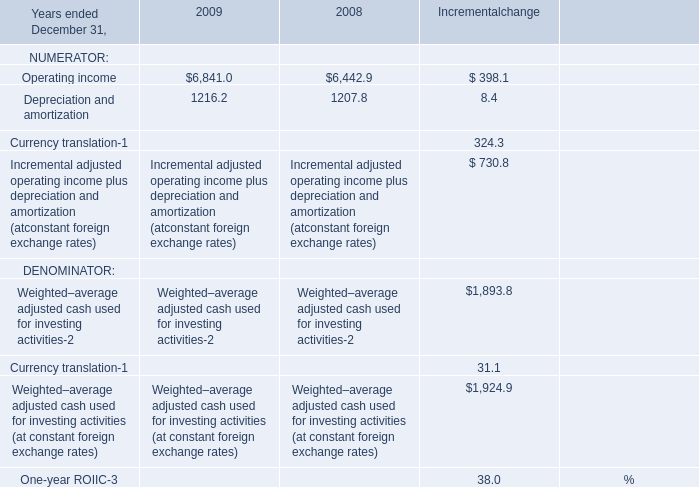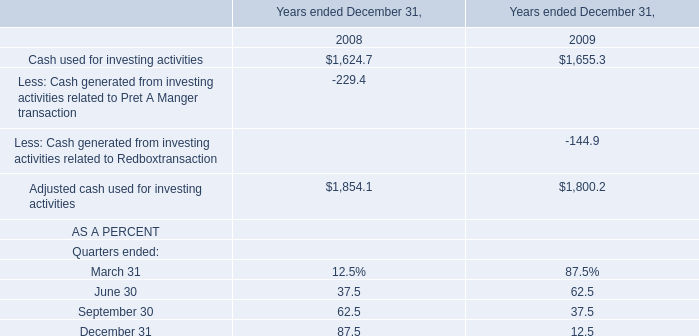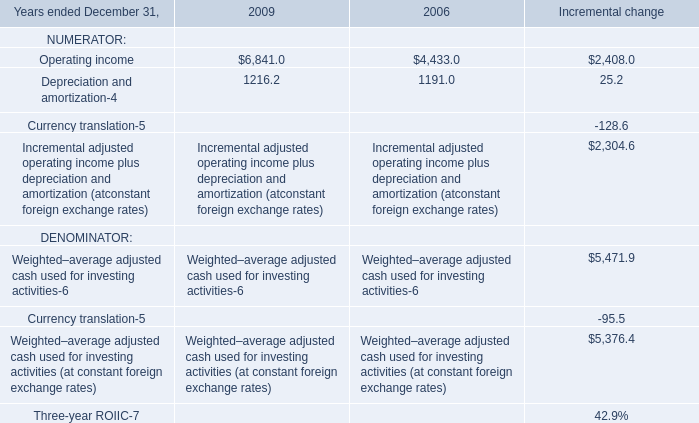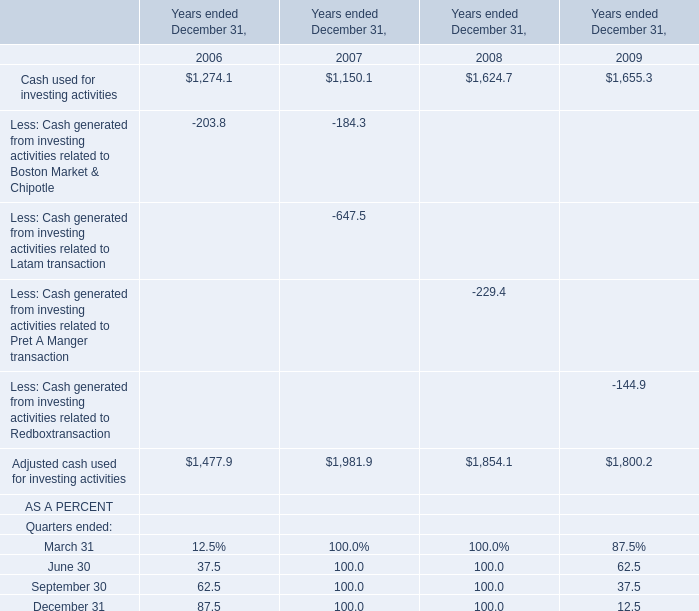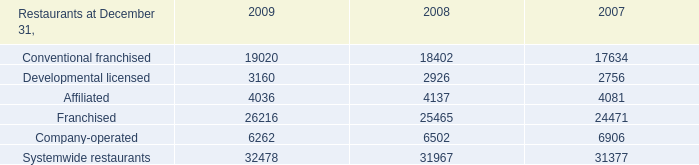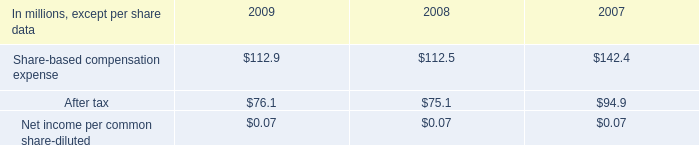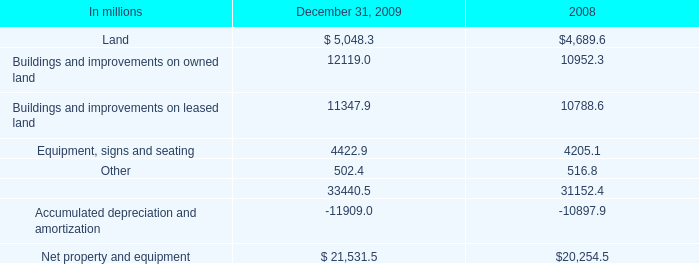What will Cash used for investing activities be like in 2010 if it develops with the same increasing rate as current? 
Computations: (1655.3 * (1 + ((1655.3 - 1624.7) / 1624.7)))
Answer: 1686.47633. 